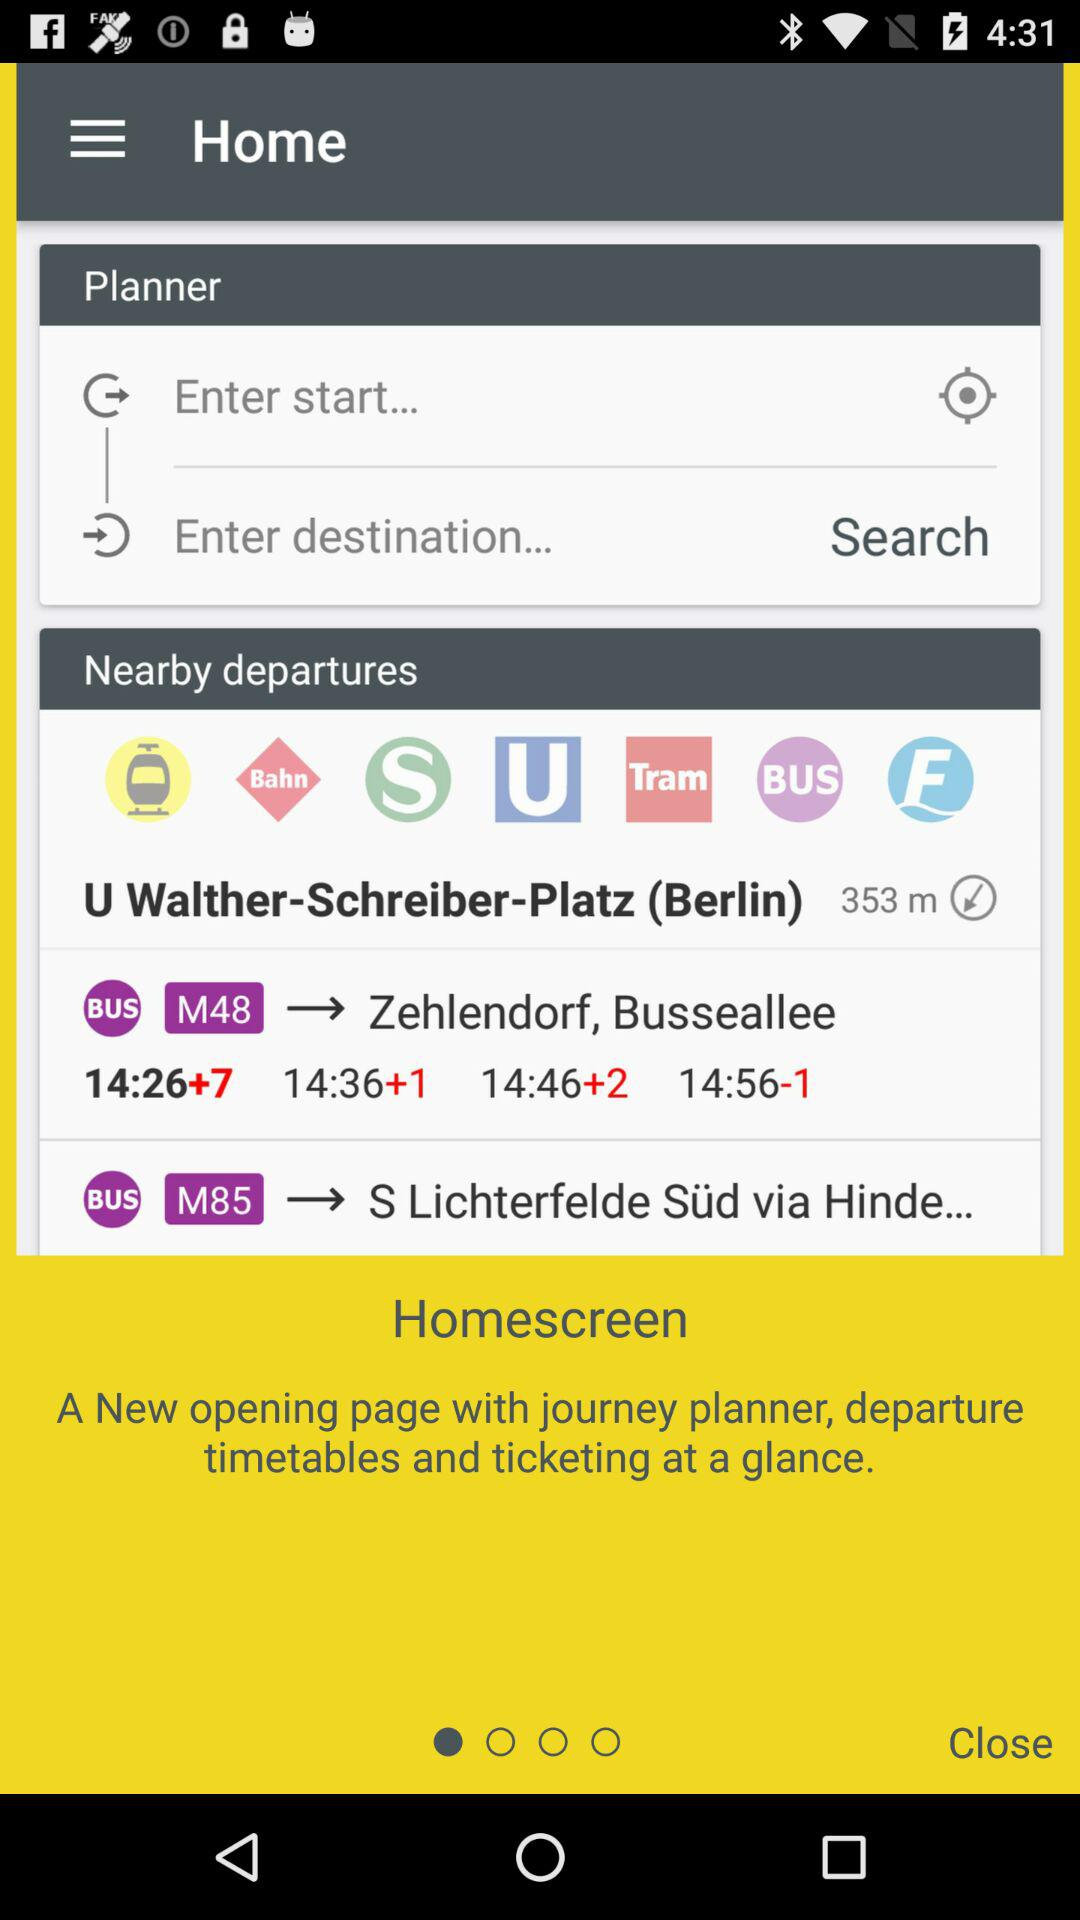What is the name of the application?
When the provided information is insufficient, respond with <no answer>. <no answer> 